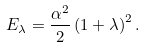<formula> <loc_0><loc_0><loc_500><loc_500>E _ { \lambda } = \frac { \alpha ^ { 2 } } { 2 } \left ( 1 + \lambda \right ) ^ { 2 } .</formula> 